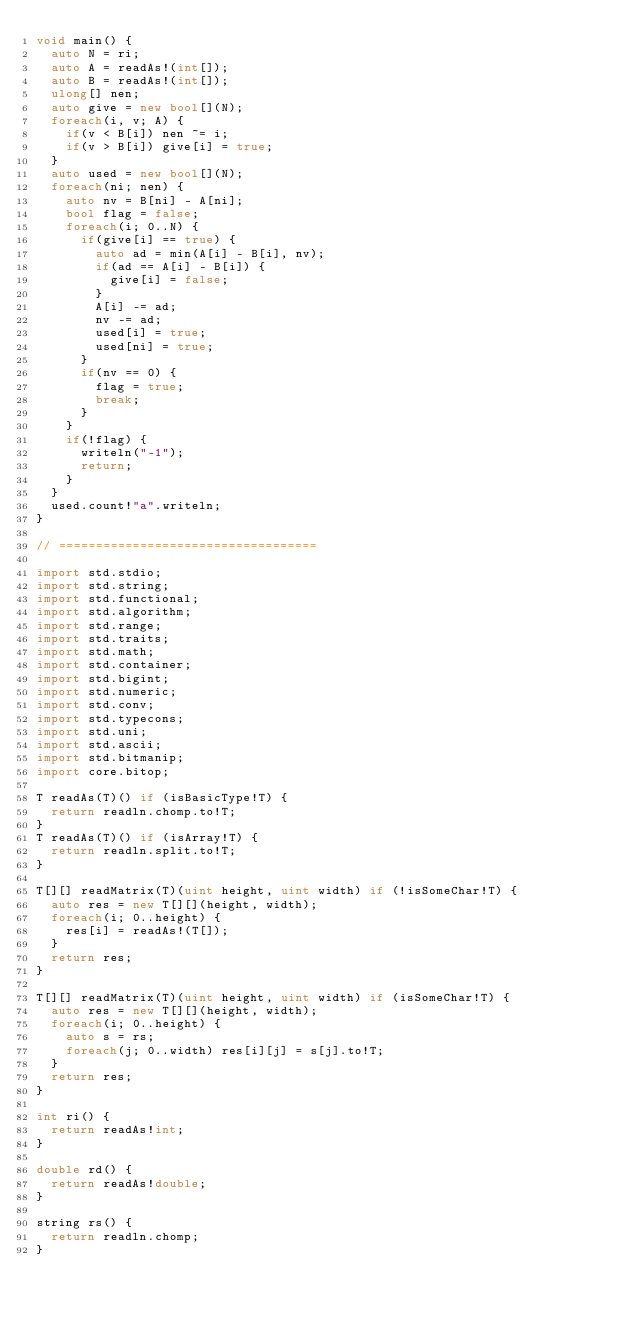<code> <loc_0><loc_0><loc_500><loc_500><_D_>void main() {
	auto N = ri;
	auto A = readAs!(int[]);
	auto B = readAs!(int[]);
	ulong[] nen;
	auto give = new bool[](N);
	foreach(i, v; A) {
		if(v < B[i]) nen ~= i;
		if(v > B[i]) give[i] = true;
	}
	auto used = new bool[](N);
	foreach(ni; nen) {
		auto nv = B[ni] - A[ni];
		bool flag = false;
		foreach(i; 0..N) {
			if(give[i] == true) {
				auto ad = min(A[i] - B[i], nv);
				if(ad == A[i] - B[i]) {
					give[i] = false;
				}
				A[i] -= ad;
				nv -= ad;
				used[i] = true;
				used[ni] = true;
			}
			if(nv == 0) {
				flag = true;
				break;
			}
		}
		if(!flag) {
			writeln("-1");
			return;
		}
	}
	used.count!"a".writeln;
}

// ===================================

import std.stdio;
import std.string;
import std.functional;
import std.algorithm;
import std.range;
import std.traits;
import std.math;
import std.container;
import std.bigint;
import std.numeric;
import std.conv;
import std.typecons;
import std.uni;
import std.ascii;
import std.bitmanip;
import core.bitop;

T readAs(T)() if (isBasicType!T) {
	return readln.chomp.to!T;
}
T readAs(T)() if (isArray!T) {
	return readln.split.to!T;
}

T[][] readMatrix(T)(uint height, uint width) if (!isSomeChar!T) {
	auto res = new T[][](height, width);
	foreach(i; 0..height) {
		res[i] = readAs!(T[]);
	}
	return res;
}

T[][] readMatrix(T)(uint height, uint width) if (isSomeChar!T) {
	auto res = new T[][](height, width);
	foreach(i; 0..height) {
		auto s = rs;
		foreach(j; 0..width) res[i][j] = s[j].to!T;
	}
	return res;
}

int ri() {
	return readAs!int;
}

double rd() {
	return readAs!double;
}

string rs() {
	return readln.chomp;
}
</code> 